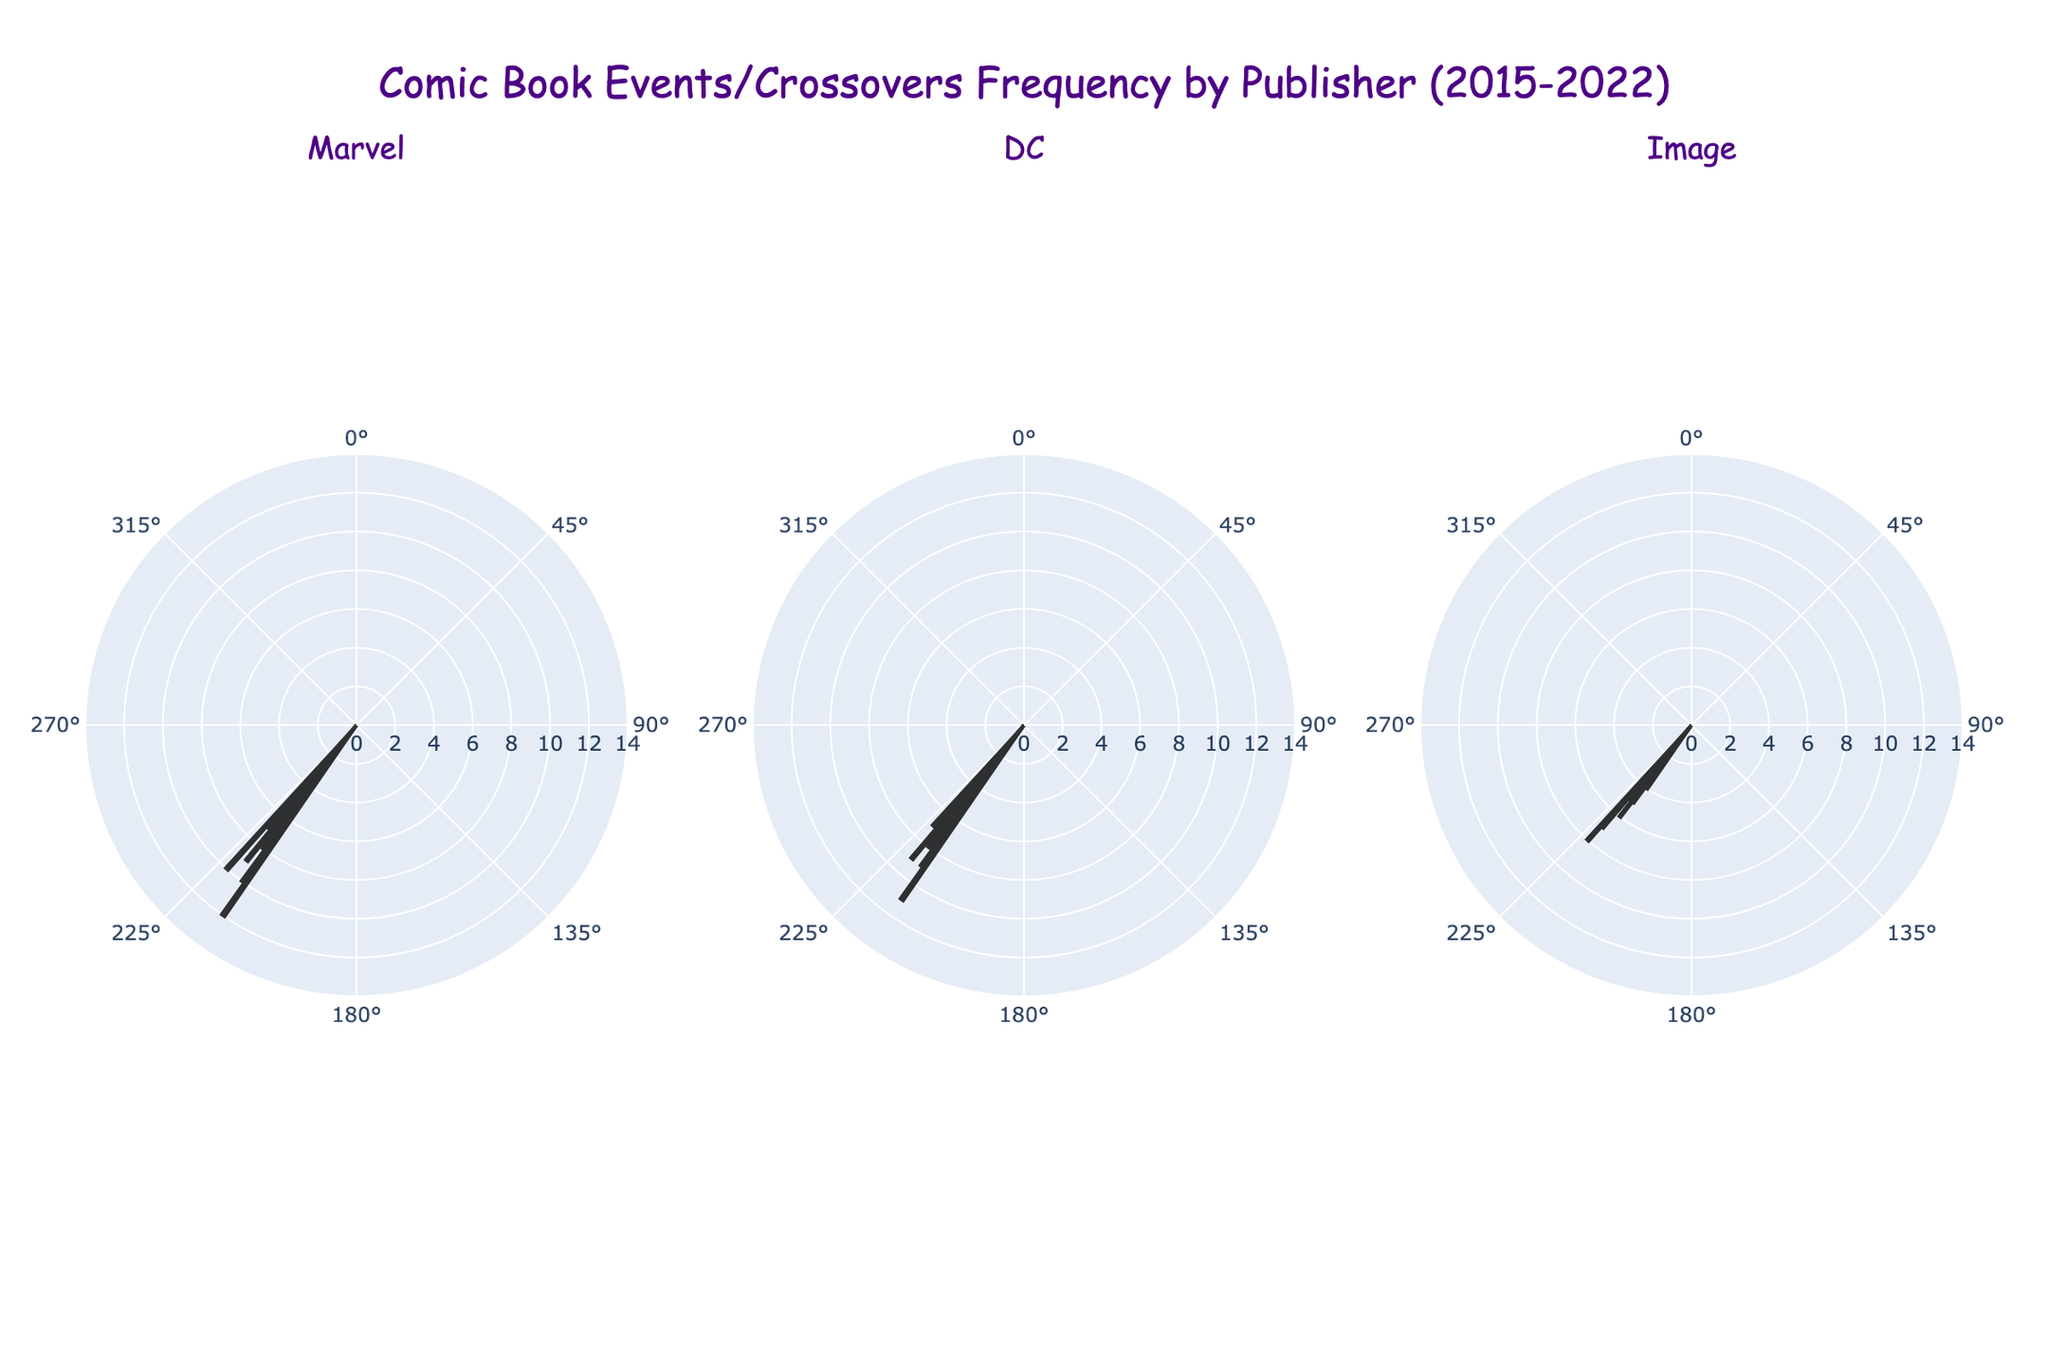What's the title of the plot? The title is displayed at the top center of the figure. It reads "Comic Book Events/Crossovers Frequency by Publisher (2015-2022)"
Answer: Comic Book Events/Crossovers Frequency by Publisher (2015-2022) Which publisher had the highest frequency for any single event? By looking at the bars representing the frequency of events, the highest single event frequency is represented by Marvel for "Secret Wars" in 2015 with a frequency of 12.
Answer: Marvel How many unique years are displayed in the plot? Each subplot is divided into different segments for each year. Since the data covers from 2015 to 2022, it includes 8 unique years.
Answer: 8 What is the color used to represent DC? The color representing DC in the subplot is Deep Sky Blue, which is the second color listed.
Answer: Deep Sky Blue What's the total frequency of Marvel events from 2015 to 2022? Add up all the frequencies for Marvel events: 12 (2015) + 10 (2016) + 8 (2017) + 6 (2018) + 9 (2019) + 7 (2020) + 5 (2021) + 10 (2022) = 67
Answer: 67 Which year had the lowest frequency of events across all publishers? Scan the subplots for the minimum frequency value and the corresponding year across all publishers. The lowest frequency is 3, for Image's "Zodiac Starforce" in 2016.
Answer: 2016 Compare the cumulative frequency of events for Marvel and DC over the given period. Which is higher and by how much? Sum up the frequencies for both publishers and calculate the difference. Marvel: 67, DC: 62. Marvel has a higher frequency by 5 events.
Answer: Marvel by 5 Which publisher had the most events in 2022? Refer to the segments labeled 2022 in each subplot and compare the frequency values. Marvel and Image both have the highest frequency of 8 in 2022.
Answer: Marvel and Image What is the average frequency of events for Image publisher from 2015 to 2022? Sum up all the frequency numbers for Image and divide by the number of years:
(4 + 3 + 5 + 6 + 5 + 4 + 7 + 8) / 8 = 5.25
Answer: 5.25 What's the trend of events frequency for DC from 2015 to 2022 – increasing, decreasing, or fluctuating? Analyze the bar values for DC over the years. The frequencies are 11, 9, 7, 8, 6, 9, 5, 7, which show a fluctuating trend, not consistently increasing or decreasing.
Answer: Fluctuating 